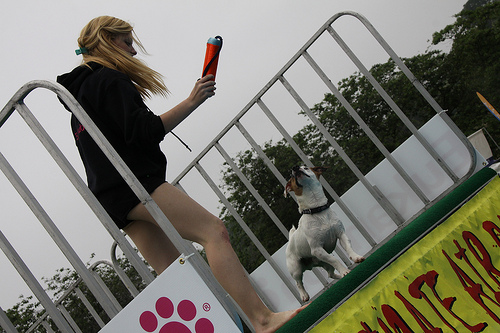<image>
Is the dog on the dog trainer? No. The dog is not positioned on the dog trainer. They may be near each other, but the dog is not supported by or resting on top of the dog trainer. 